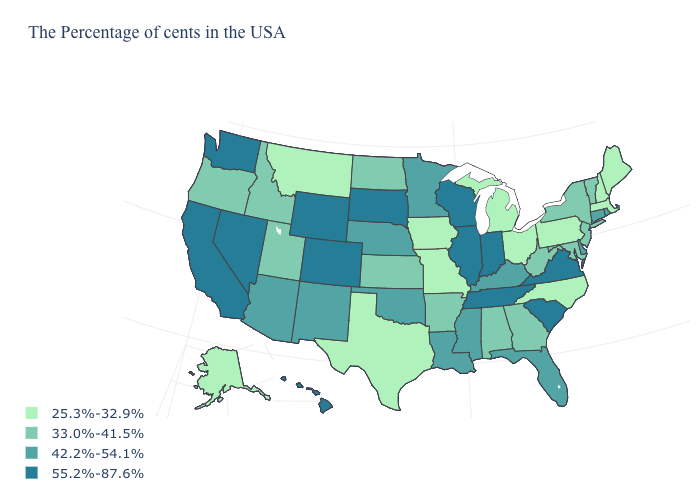Which states have the highest value in the USA?
Answer briefly. Virginia, South Carolina, Indiana, Tennessee, Wisconsin, Illinois, South Dakota, Wyoming, Colorado, Nevada, California, Washington, Hawaii. Does Ohio have a lower value than California?
Quick response, please. Yes. Among the states that border New Jersey , does Pennsylvania have the lowest value?
Write a very short answer. Yes. What is the value of Virginia?
Short answer required. 55.2%-87.6%. What is the value of Wisconsin?
Quick response, please. 55.2%-87.6%. Name the states that have a value in the range 55.2%-87.6%?
Concise answer only. Virginia, South Carolina, Indiana, Tennessee, Wisconsin, Illinois, South Dakota, Wyoming, Colorado, Nevada, California, Washington, Hawaii. Name the states that have a value in the range 42.2%-54.1%?
Give a very brief answer. Rhode Island, Connecticut, Delaware, Florida, Kentucky, Mississippi, Louisiana, Minnesota, Nebraska, Oklahoma, New Mexico, Arizona. Name the states that have a value in the range 33.0%-41.5%?
Short answer required. Vermont, New York, New Jersey, Maryland, West Virginia, Georgia, Alabama, Arkansas, Kansas, North Dakota, Utah, Idaho, Oregon. Does California have a lower value than Wyoming?
Be succinct. No. Name the states that have a value in the range 25.3%-32.9%?
Write a very short answer. Maine, Massachusetts, New Hampshire, Pennsylvania, North Carolina, Ohio, Michigan, Missouri, Iowa, Texas, Montana, Alaska. Name the states that have a value in the range 25.3%-32.9%?
Keep it brief. Maine, Massachusetts, New Hampshire, Pennsylvania, North Carolina, Ohio, Michigan, Missouri, Iowa, Texas, Montana, Alaska. Does Mississippi have the lowest value in the USA?
Keep it brief. No. Name the states that have a value in the range 25.3%-32.9%?
Quick response, please. Maine, Massachusetts, New Hampshire, Pennsylvania, North Carolina, Ohio, Michigan, Missouri, Iowa, Texas, Montana, Alaska. Name the states that have a value in the range 25.3%-32.9%?
Short answer required. Maine, Massachusetts, New Hampshire, Pennsylvania, North Carolina, Ohio, Michigan, Missouri, Iowa, Texas, Montana, Alaska. Which states hav the highest value in the MidWest?
Answer briefly. Indiana, Wisconsin, Illinois, South Dakota. 